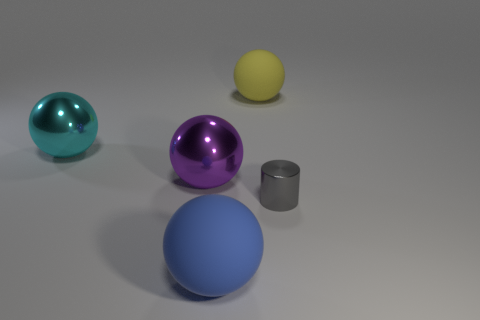There is a big blue matte object to the left of the tiny gray shiny cylinder in front of the object that is behind the cyan thing; what is its shape?
Provide a succinct answer. Sphere. Is the number of big purple balls greater than the number of purple rubber objects?
Make the answer very short. Yes. There is a purple object that is the same shape as the cyan metal object; what is its material?
Give a very brief answer. Metal. Is the material of the cylinder the same as the large yellow sphere?
Provide a succinct answer. No. Are there more rubber things on the right side of the purple metal thing than tiny objects?
Your answer should be compact. Yes. What material is the ball that is in front of the shiny object to the right of the rubber object in front of the large purple object?
Give a very brief answer. Rubber. What number of things are small cylinders or metallic things in front of the large purple thing?
Ensure brevity in your answer.  1. There is a rubber sphere behind the big blue thing; is its color the same as the cylinder?
Offer a very short reply. No. Is the number of large objects that are to the right of the tiny cylinder greater than the number of objects that are right of the big purple ball?
Offer a terse response. No. Is there anything else that has the same color as the small metallic thing?
Provide a succinct answer. No. 